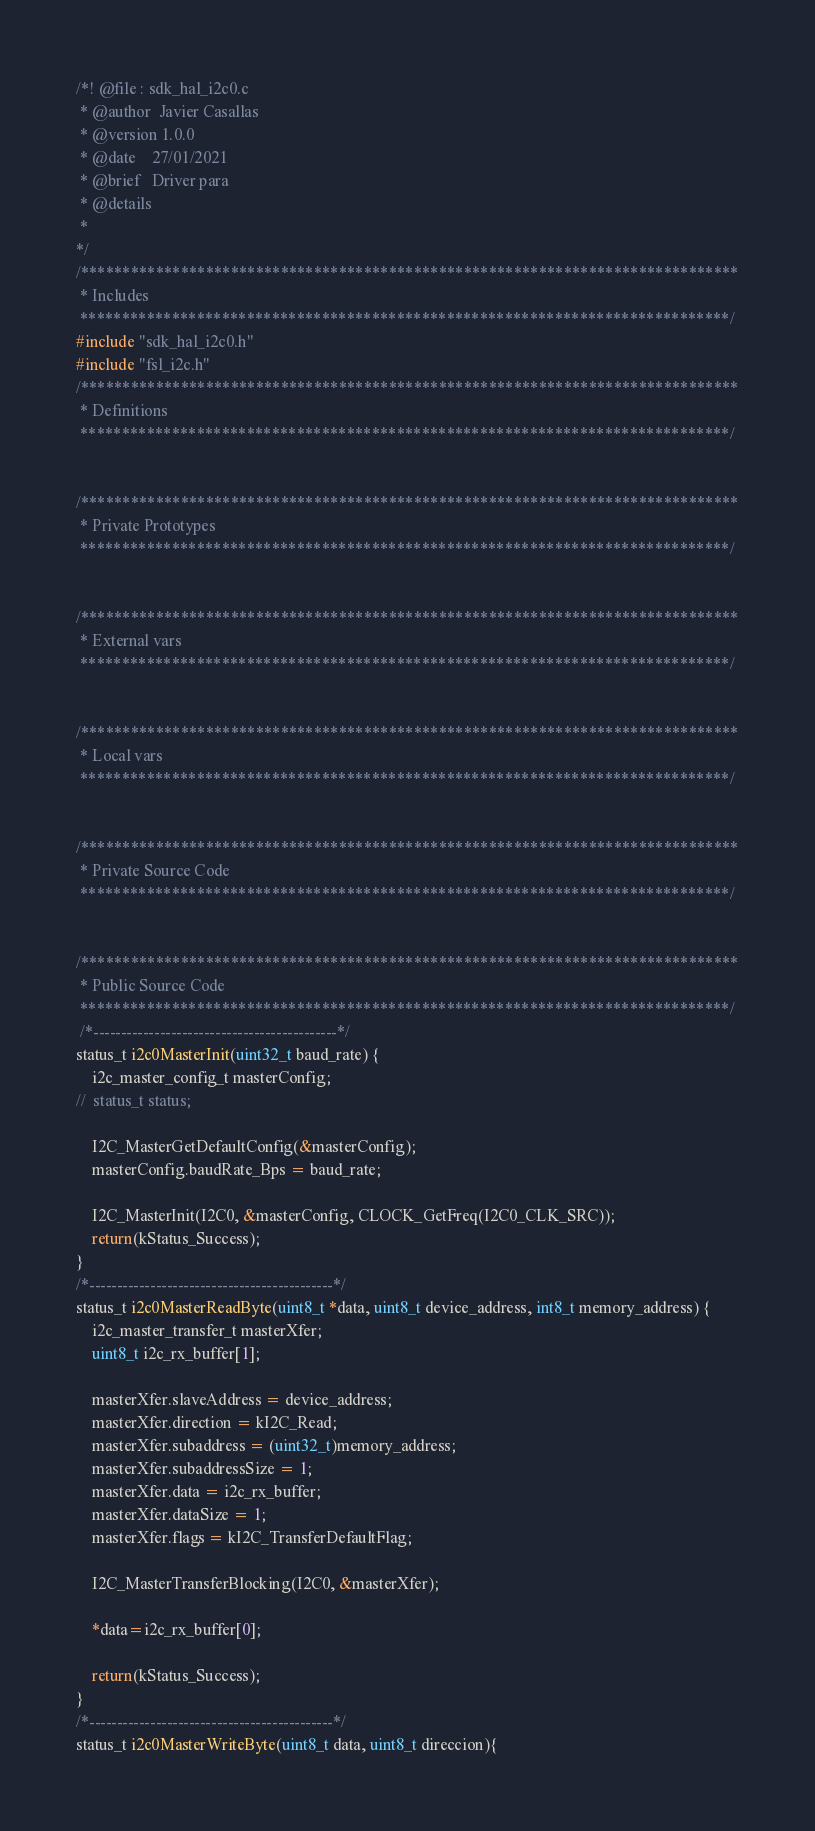Convert code to text. <code><loc_0><loc_0><loc_500><loc_500><_C_>/*! @file : sdk_hal_i2c0.c
 * @author  Javier Casallas
 * @version 1.0.0
 * @date    27/01/2021
 * @brief   Driver para 
 * @details
 *
*/
/*******************************************************************************
 * Includes
 ******************************************************************************/
#include "sdk_hal_i2c0.h"
#include "fsl_i2c.h"
/*******************************************************************************
 * Definitions
 ******************************************************************************/


/*******************************************************************************
 * Private Prototypes
 ******************************************************************************/


/*******************************************************************************
 * External vars
 ******************************************************************************/


/*******************************************************************************
 * Local vars
 ******************************************************************************/


/*******************************************************************************
 * Private Source Code
 ******************************************************************************/


/*******************************************************************************
 * Public Source Code
 ******************************************************************************/
 /*--------------------------------------------*/
status_t i2c0MasterInit(uint32_t baud_rate) {
	i2c_master_config_t masterConfig;
//	status_t status;

	I2C_MasterGetDefaultConfig(&masterConfig);
    masterConfig.baudRate_Bps = baud_rate;

    I2C_MasterInit(I2C0, &masterConfig, CLOCK_GetFreq(I2C0_CLK_SRC));
	return(kStatus_Success);
}
/*--------------------------------------------*/
status_t i2c0MasterReadByte(uint8_t *data, uint8_t device_address, int8_t memory_address) {
	i2c_master_transfer_t masterXfer;
	uint8_t i2c_rx_buffer[1];

    masterXfer.slaveAddress = device_address;
    masterXfer.direction = kI2C_Read;
    masterXfer.subaddress = (uint32_t)memory_address;
    masterXfer.subaddressSize = 1;
    masterXfer.data = i2c_rx_buffer;
    masterXfer.dataSize = 1;
    masterXfer.flags = kI2C_TransferDefaultFlag;

    I2C_MasterTransferBlocking(I2C0, &masterXfer);

    *data=i2c_rx_buffer[0];

    return(kStatus_Success);
}
/*--------------------------------------------*/
status_t i2c0MasterWriteByte(uint8_t data, uint8_t direccion){</code> 